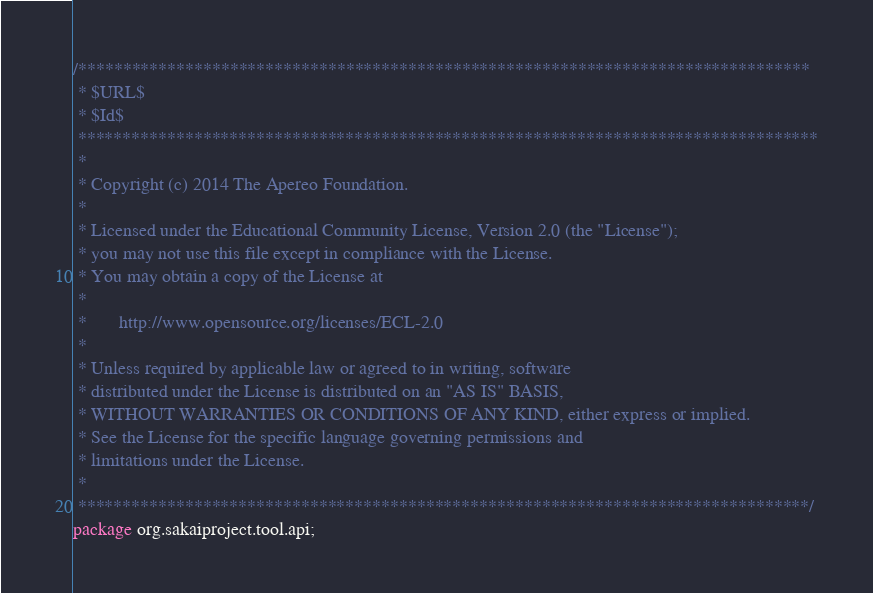Convert code to text. <code><loc_0><loc_0><loc_500><loc_500><_Java_>/**********************************************************************************
 * $URL$
 * $Id$
 ***********************************************************************************
 *
 * Copyright (c) 2014 The Apereo Foundation.
 *
 * Licensed under the Educational Community License, Version 2.0 (the "License");
 * you may not use this file except in compliance with the License.
 * You may obtain a copy of the License at
 *
 *       http://www.opensource.org/licenses/ECL-2.0
 *
 * Unless required by applicable law or agreed to in writing, software
 * distributed under the License is distributed on an "AS IS" BASIS,
 * WITHOUT WARRANTIES OR CONDITIONS OF ANY KIND, either express or implied.
 * See the License for the specific language governing permissions and
 * limitations under the License.
 *
 **********************************************************************************/
package org.sakaiproject.tool.api;
</code> 